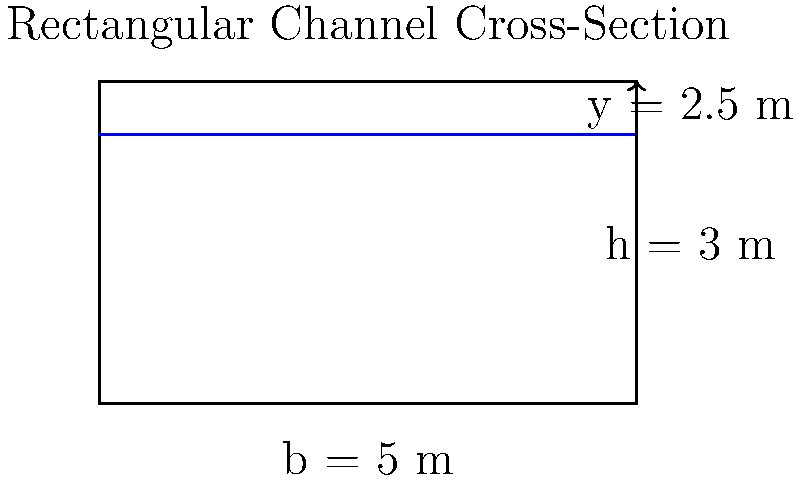A rectangular channel has a width of 5 meters and a total depth of 3 meters. If the water depth in the channel is 2.5 meters, what is the cross-sectional area of water flow? To find the cross-sectional area of water flow in a rectangular channel, we need to follow these steps:

1. Identify the relevant dimensions:
   - Channel width (b) = 5 m
   - Water depth (y) = 2.5 m

2. Recall the formula for the area of a rectangle:
   $A = b \times h$, where A is area, b is base (width), and h is height

3. In this case, the width of the channel is the base, and the water depth is the height:
   $A = b \times y$

4. Substitute the known values into the formula:
   $A = 5 \text{ m} \times 2.5 \text{ m}$

5. Calculate the result:
   $A = 12.5 \text{ m}^2$

Therefore, the cross-sectional area of water flow in the rectangular channel is 12.5 square meters.
Answer: 12.5 m² 